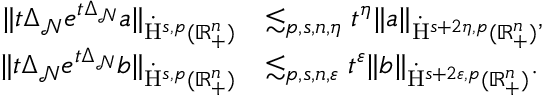<formula> <loc_0><loc_0><loc_500><loc_500>\begin{array} { r l } { \| t \Delta _ { \mathcal { N } } e ^ { t \Delta _ { \mathcal { N } } } a \| _ { \dot { H } ^ { s , p } ( \mathbb { R } _ { + } ^ { n } ) } } & { \lesssim _ { p , s , n , \eta } t ^ { \eta } \| a \| _ { \dot { H } ^ { s + 2 \eta , p } ( \mathbb { R } _ { + } ^ { n } ) } , } \\ { \| t \Delta _ { \mathcal { N } } e ^ { t \Delta _ { \mathcal { N } } } b \| _ { \dot { H } ^ { s , p } ( \mathbb { R } _ { + } ^ { n } ) } } & { \lesssim _ { p , s , n , \varepsilon } t ^ { \varepsilon } \| b \| _ { \dot { H } ^ { s + 2 \varepsilon , p } ( \mathbb { R } _ { + } ^ { n } ) } . } \end{array}</formula> 